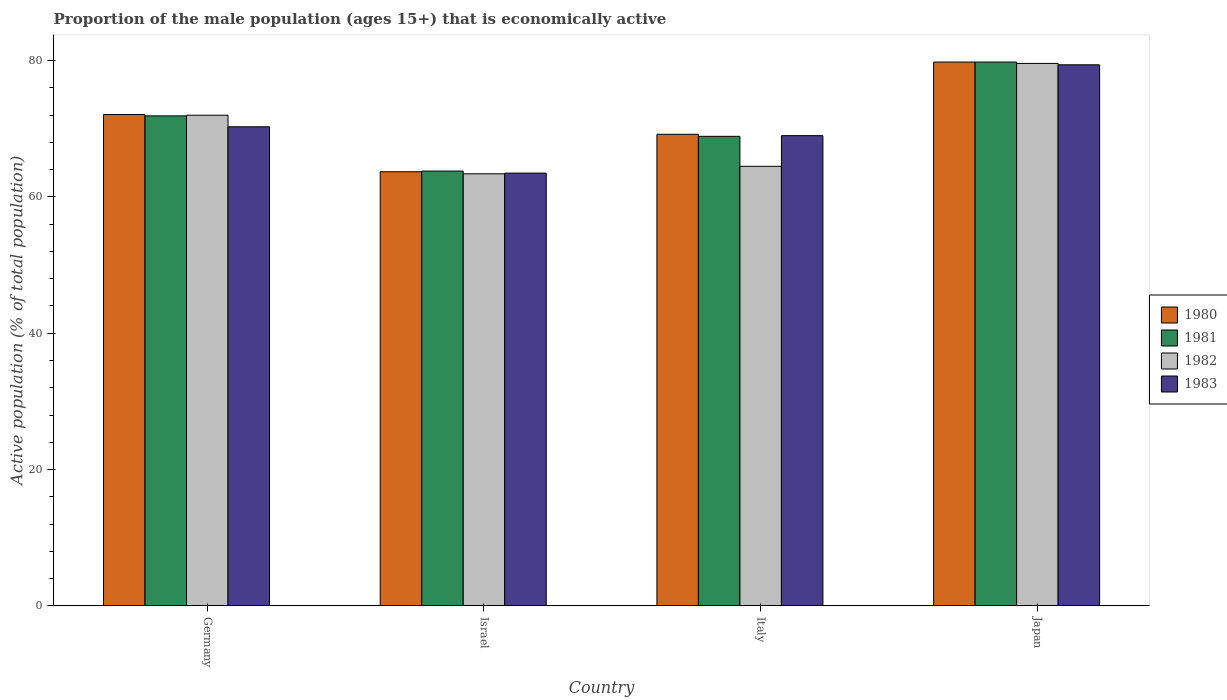How many different coloured bars are there?
Make the answer very short. 4. Are the number of bars per tick equal to the number of legend labels?
Your answer should be compact. Yes. Are the number of bars on each tick of the X-axis equal?
Provide a short and direct response. Yes. How many bars are there on the 1st tick from the left?
Your response must be concise. 4. What is the label of the 4th group of bars from the left?
Provide a succinct answer. Japan. In how many cases, is the number of bars for a given country not equal to the number of legend labels?
Offer a terse response. 0. What is the proportion of the male population that is economically active in 1981 in Italy?
Keep it short and to the point. 68.9. Across all countries, what is the maximum proportion of the male population that is economically active in 1981?
Ensure brevity in your answer.  79.8. Across all countries, what is the minimum proportion of the male population that is economically active in 1980?
Your answer should be compact. 63.7. What is the total proportion of the male population that is economically active in 1981 in the graph?
Provide a short and direct response. 284.4. What is the difference between the proportion of the male population that is economically active in 1983 in Germany and that in Israel?
Give a very brief answer. 6.8. What is the difference between the proportion of the male population that is economically active in 1981 in Japan and the proportion of the male population that is economically active in 1983 in Israel?
Keep it short and to the point. 16.3. What is the average proportion of the male population that is economically active in 1980 per country?
Your answer should be very brief. 71.2. What is the difference between the proportion of the male population that is economically active of/in 1981 and proportion of the male population that is economically active of/in 1980 in Japan?
Your answer should be very brief. 0. In how many countries, is the proportion of the male population that is economically active in 1981 greater than 32 %?
Make the answer very short. 4. What is the ratio of the proportion of the male population that is economically active in 1980 in Israel to that in Japan?
Keep it short and to the point. 0.8. Is the proportion of the male population that is economically active in 1983 in Italy less than that in Japan?
Offer a very short reply. Yes. Is the difference between the proportion of the male population that is economically active in 1981 in Germany and Japan greater than the difference between the proportion of the male population that is economically active in 1980 in Germany and Japan?
Provide a succinct answer. No. What is the difference between the highest and the second highest proportion of the male population that is economically active in 1982?
Offer a terse response. 7.5. What is the difference between the highest and the lowest proportion of the male population that is economically active in 1980?
Provide a short and direct response. 16.1. Is the sum of the proportion of the male population that is economically active in 1982 in Italy and Japan greater than the maximum proportion of the male population that is economically active in 1980 across all countries?
Offer a very short reply. Yes. Is it the case that in every country, the sum of the proportion of the male population that is economically active in 1982 and proportion of the male population that is economically active in 1981 is greater than the sum of proportion of the male population that is economically active in 1983 and proportion of the male population that is economically active in 1980?
Provide a short and direct response. No. What does the 3rd bar from the left in Japan represents?
Provide a short and direct response. 1982. What does the 2nd bar from the right in Germany represents?
Ensure brevity in your answer.  1982. Where does the legend appear in the graph?
Your answer should be compact. Center right. What is the title of the graph?
Your response must be concise. Proportion of the male population (ages 15+) that is economically active. Does "2011" appear as one of the legend labels in the graph?
Your response must be concise. No. What is the label or title of the Y-axis?
Offer a very short reply. Active population (% of total population). What is the Active population (% of total population) in 1980 in Germany?
Ensure brevity in your answer.  72.1. What is the Active population (% of total population) of 1981 in Germany?
Your response must be concise. 71.9. What is the Active population (% of total population) of 1983 in Germany?
Make the answer very short. 70.3. What is the Active population (% of total population) in 1980 in Israel?
Provide a short and direct response. 63.7. What is the Active population (% of total population) of 1981 in Israel?
Offer a terse response. 63.8. What is the Active population (% of total population) of 1982 in Israel?
Keep it short and to the point. 63.4. What is the Active population (% of total population) in 1983 in Israel?
Your answer should be very brief. 63.5. What is the Active population (% of total population) in 1980 in Italy?
Provide a succinct answer. 69.2. What is the Active population (% of total population) of 1981 in Italy?
Keep it short and to the point. 68.9. What is the Active population (% of total population) in 1982 in Italy?
Make the answer very short. 64.5. What is the Active population (% of total population) in 1980 in Japan?
Keep it short and to the point. 79.8. What is the Active population (% of total population) in 1981 in Japan?
Ensure brevity in your answer.  79.8. What is the Active population (% of total population) in 1982 in Japan?
Your answer should be very brief. 79.6. What is the Active population (% of total population) in 1983 in Japan?
Ensure brevity in your answer.  79.4. Across all countries, what is the maximum Active population (% of total population) of 1980?
Give a very brief answer. 79.8. Across all countries, what is the maximum Active population (% of total population) in 1981?
Keep it short and to the point. 79.8. Across all countries, what is the maximum Active population (% of total population) in 1982?
Offer a terse response. 79.6. Across all countries, what is the maximum Active population (% of total population) in 1983?
Ensure brevity in your answer.  79.4. Across all countries, what is the minimum Active population (% of total population) in 1980?
Your answer should be very brief. 63.7. Across all countries, what is the minimum Active population (% of total population) in 1981?
Your response must be concise. 63.8. Across all countries, what is the minimum Active population (% of total population) in 1982?
Offer a very short reply. 63.4. Across all countries, what is the minimum Active population (% of total population) in 1983?
Make the answer very short. 63.5. What is the total Active population (% of total population) in 1980 in the graph?
Make the answer very short. 284.8. What is the total Active population (% of total population) of 1981 in the graph?
Your answer should be very brief. 284.4. What is the total Active population (% of total population) of 1982 in the graph?
Give a very brief answer. 279.5. What is the total Active population (% of total population) of 1983 in the graph?
Provide a short and direct response. 282.2. What is the difference between the Active population (% of total population) in 1981 in Germany and that in Israel?
Make the answer very short. 8.1. What is the difference between the Active population (% of total population) in 1983 in Germany and that in Israel?
Make the answer very short. 6.8. What is the difference between the Active population (% of total population) of 1982 in Germany and that in Italy?
Offer a very short reply. 7.5. What is the difference between the Active population (% of total population) of 1983 in Germany and that in Italy?
Ensure brevity in your answer.  1.3. What is the difference between the Active population (% of total population) of 1980 in Germany and that in Japan?
Provide a succinct answer. -7.7. What is the difference between the Active population (% of total population) of 1981 in Germany and that in Japan?
Provide a succinct answer. -7.9. What is the difference between the Active population (% of total population) in 1982 in Germany and that in Japan?
Provide a succinct answer. -7.6. What is the difference between the Active population (% of total population) in 1983 in Germany and that in Japan?
Make the answer very short. -9.1. What is the difference between the Active population (% of total population) in 1980 in Israel and that in Italy?
Give a very brief answer. -5.5. What is the difference between the Active population (% of total population) in 1982 in Israel and that in Italy?
Your answer should be compact. -1.1. What is the difference between the Active population (% of total population) in 1983 in Israel and that in Italy?
Provide a succinct answer. -5.5. What is the difference between the Active population (% of total population) in 1980 in Israel and that in Japan?
Offer a terse response. -16.1. What is the difference between the Active population (% of total population) in 1981 in Israel and that in Japan?
Provide a succinct answer. -16. What is the difference between the Active population (% of total population) of 1982 in Israel and that in Japan?
Keep it short and to the point. -16.2. What is the difference between the Active population (% of total population) in 1983 in Israel and that in Japan?
Offer a very short reply. -15.9. What is the difference between the Active population (% of total population) in 1980 in Italy and that in Japan?
Your answer should be very brief. -10.6. What is the difference between the Active population (% of total population) of 1982 in Italy and that in Japan?
Your answer should be very brief. -15.1. What is the difference between the Active population (% of total population) in 1980 in Germany and the Active population (% of total population) in 1981 in Israel?
Make the answer very short. 8.3. What is the difference between the Active population (% of total population) in 1981 in Germany and the Active population (% of total population) in 1982 in Israel?
Your answer should be very brief. 8.5. What is the difference between the Active population (% of total population) in 1980 in Germany and the Active population (% of total population) in 1981 in Italy?
Provide a short and direct response. 3.2. What is the difference between the Active population (% of total population) of 1980 in Germany and the Active population (% of total population) of 1983 in Italy?
Offer a terse response. 3.1. What is the difference between the Active population (% of total population) in 1981 in Germany and the Active population (% of total population) in 1982 in Italy?
Provide a succinct answer. 7.4. What is the difference between the Active population (% of total population) in 1981 in Germany and the Active population (% of total population) in 1983 in Italy?
Offer a terse response. 2.9. What is the difference between the Active population (% of total population) of 1980 in Germany and the Active population (% of total population) of 1981 in Japan?
Provide a succinct answer. -7.7. What is the difference between the Active population (% of total population) in 1980 in Germany and the Active population (% of total population) in 1983 in Japan?
Provide a short and direct response. -7.3. What is the difference between the Active population (% of total population) of 1981 in Germany and the Active population (% of total population) of 1982 in Japan?
Make the answer very short. -7.7. What is the difference between the Active population (% of total population) in 1982 in Germany and the Active population (% of total population) in 1983 in Japan?
Ensure brevity in your answer.  -7.4. What is the difference between the Active population (% of total population) of 1980 in Israel and the Active population (% of total population) of 1982 in Italy?
Your answer should be compact. -0.8. What is the difference between the Active population (% of total population) in 1980 in Israel and the Active population (% of total population) in 1983 in Italy?
Your answer should be very brief. -5.3. What is the difference between the Active population (% of total population) of 1981 in Israel and the Active population (% of total population) of 1983 in Italy?
Ensure brevity in your answer.  -5.2. What is the difference between the Active population (% of total population) of 1982 in Israel and the Active population (% of total population) of 1983 in Italy?
Ensure brevity in your answer.  -5.6. What is the difference between the Active population (% of total population) of 1980 in Israel and the Active population (% of total population) of 1981 in Japan?
Ensure brevity in your answer.  -16.1. What is the difference between the Active population (% of total population) of 1980 in Israel and the Active population (% of total population) of 1982 in Japan?
Offer a very short reply. -15.9. What is the difference between the Active population (% of total population) of 1980 in Israel and the Active population (% of total population) of 1983 in Japan?
Provide a succinct answer. -15.7. What is the difference between the Active population (% of total population) of 1981 in Israel and the Active population (% of total population) of 1982 in Japan?
Make the answer very short. -15.8. What is the difference between the Active population (% of total population) in 1981 in Israel and the Active population (% of total population) in 1983 in Japan?
Ensure brevity in your answer.  -15.6. What is the difference between the Active population (% of total population) in 1980 in Italy and the Active population (% of total population) in 1982 in Japan?
Your answer should be very brief. -10.4. What is the difference between the Active population (% of total population) in 1981 in Italy and the Active population (% of total population) in 1983 in Japan?
Keep it short and to the point. -10.5. What is the difference between the Active population (% of total population) in 1982 in Italy and the Active population (% of total population) in 1983 in Japan?
Offer a very short reply. -14.9. What is the average Active population (% of total population) in 1980 per country?
Make the answer very short. 71.2. What is the average Active population (% of total population) in 1981 per country?
Offer a very short reply. 71.1. What is the average Active population (% of total population) of 1982 per country?
Make the answer very short. 69.88. What is the average Active population (% of total population) in 1983 per country?
Your answer should be compact. 70.55. What is the difference between the Active population (% of total population) in 1981 and Active population (% of total population) in 1982 in Germany?
Your response must be concise. -0.1. What is the difference between the Active population (% of total population) in 1982 and Active population (% of total population) in 1983 in Germany?
Ensure brevity in your answer.  1.7. What is the difference between the Active population (% of total population) of 1980 and Active population (% of total population) of 1981 in Israel?
Make the answer very short. -0.1. What is the difference between the Active population (% of total population) of 1980 and Active population (% of total population) of 1983 in Israel?
Your answer should be compact. 0.2. What is the difference between the Active population (% of total population) of 1980 and Active population (% of total population) of 1981 in Italy?
Provide a short and direct response. 0.3. What is the difference between the Active population (% of total population) in 1980 and Active population (% of total population) in 1982 in Italy?
Your answer should be very brief. 4.7. What is the difference between the Active population (% of total population) of 1980 and Active population (% of total population) of 1982 in Japan?
Your answer should be very brief. 0.2. What is the difference between the Active population (% of total population) in 1980 and Active population (% of total population) in 1983 in Japan?
Provide a short and direct response. 0.4. What is the ratio of the Active population (% of total population) of 1980 in Germany to that in Israel?
Offer a very short reply. 1.13. What is the ratio of the Active population (% of total population) in 1981 in Germany to that in Israel?
Provide a short and direct response. 1.13. What is the ratio of the Active population (% of total population) of 1982 in Germany to that in Israel?
Give a very brief answer. 1.14. What is the ratio of the Active population (% of total population) of 1983 in Germany to that in Israel?
Ensure brevity in your answer.  1.11. What is the ratio of the Active population (% of total population) in 1980 in Germany to that in Italy?
Your answer should be compact. 1.04. What is the ratio of the Active population (% of total population) of 1981 in Germany to that in Italy?
Provide a succinct answer. 1.04. What is the ratio of the Active population (% of total population) of 1982 in Germany to that in Italy?
Offer a terse response. 1.12. What is the ratio of the Active population (% of total population) in 1983 in Germany to that in Italy?
Give a very brief answer. 1.02. What is the ratio of the Active population (% of total population) in 1980 in Germany to that in Japan?
Your answer should be compact. 0.9. What is the ratio of the Active population (% of total population) in 1981 in Germany to that in Japan?
Make the answer very short. 0.9. What is the ratio of the Active population (% of total population) of 1982 in Germany to that in Japan?
Your answer should be very brief. 0.9. What is the ratio of the Active population (% of total population) of 1983 in Germany to that in Japan?
Keep it short and to the point. 0.89. What is the ratio of the Active population (% of total population) in 1980 in Israel to that in Italy?
Keep it short and to the point. 0.92. What is the ratio of the Active population (% of total population) in 1981 in Israel to that in Italy?
Give a very brief answer. 0.93. What is the ratio of the Active population (% of total population) of 1982 in Israel to that in Italy?
Make the answer very short. 0.98. What is the ratio of the Active population (% of total population) in 1983 in Israel to that in Italy?
Provide a succinct answer. 0.92. What is the ratio of the Active population (% of total population) in 1980 in Israel to that in Japan?
Give a very brief answer. 0.8. What is the ratio of the Active population (% of total population) of 1981 in Israel to that in Japan?
Give a very brief answer. 0.8. What is the ratio of the Active population (% of total population) of 1982 in Israel to that in Japan?
Make the answer very short. 0.8. What is the ratio of the Active population (% of total population) of 1983 in Israel to that in Japan?
Keep it short and to the point. 0.8. What is the ratio of the Active population (% of total population) of 1980 in Italy to that in Japan?
Your answer should be compact. 0.87. What is the ratio of the Active population (% of total population) of 1981 in Italy to that in Japan?
Keep it short and to the point. 0.86. What is the ratio of the Active population (% of total population) of 1982 in Italy to that in Japan?
Keep it short and to the point. 0.81. What is the ratio of the Active population (% of total population) of 1983 in Italy to that in Japan?
Offer a very short reply. 0.87. What is the difference between the highest and the second highest Active population (% of total population) in 1981?
Your answer should be very brief. 7.9. What is the difference between the highest and the second highest Active population (% of total population) in 1982?
Offer a terse response. 7.6. What is the difference between the highest and the lowest Active population (% of total population) of 1982?
Give a very brief answer. 16.2. 